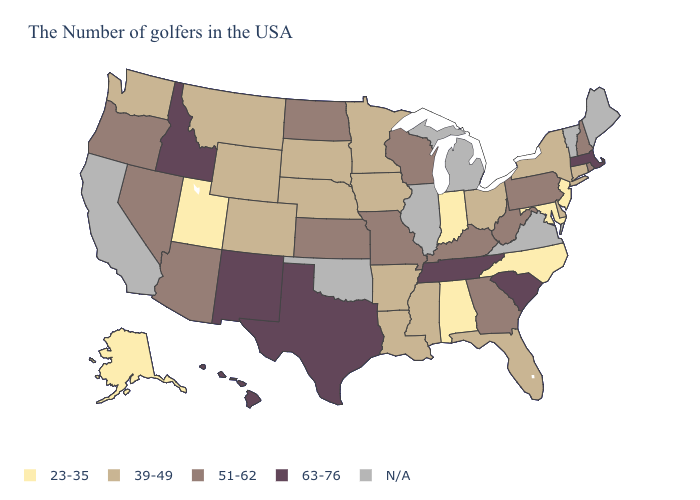What is the highest value in states that border New York?
Short answer required. 63-76. Does Hawaii have the lowest value in the West?
Quick response, please. No. Which states have the highest value in the USA?
Short answer required. Massachusetts, South Carolina, Tennessee, Texas, New Mexico, Idaho, Hawaii. Name the states that have a value in the range 23-35?
Be succinct. New Jersey, Maryland, North Carolina, Indiana, Alabama, Utah, Alaska. What is the value of Illinois?
Concise answer only. N/A. What is the lowest value in the MidWest?
Short answer required. 23-35. Which states hav the highest value in the Northeast?
Quick response, please. Massachusetts. Which states hav the highest value in the South?
Keep it brief. South Carolina, Tennessee, Texas. What is the highest value in the USA?
Be succinct. 63-76. What is the value of Wyoming?
Concise answer only. 39-49. Name the states that have a value in the range 39-49?
Answer briefly. Connecticut, New York, Delaware, Ohio, Florida, Mississippi, Louisiana, Arkansas, Minnesota, Iowa, Nebraska, South Dakota, Wyoming, Colorado, Montana, Washington. What is the value of Nebraska?
Write a very short answer. 39-49. What is the value of Maryland?
Keep it brief. 23-35. 